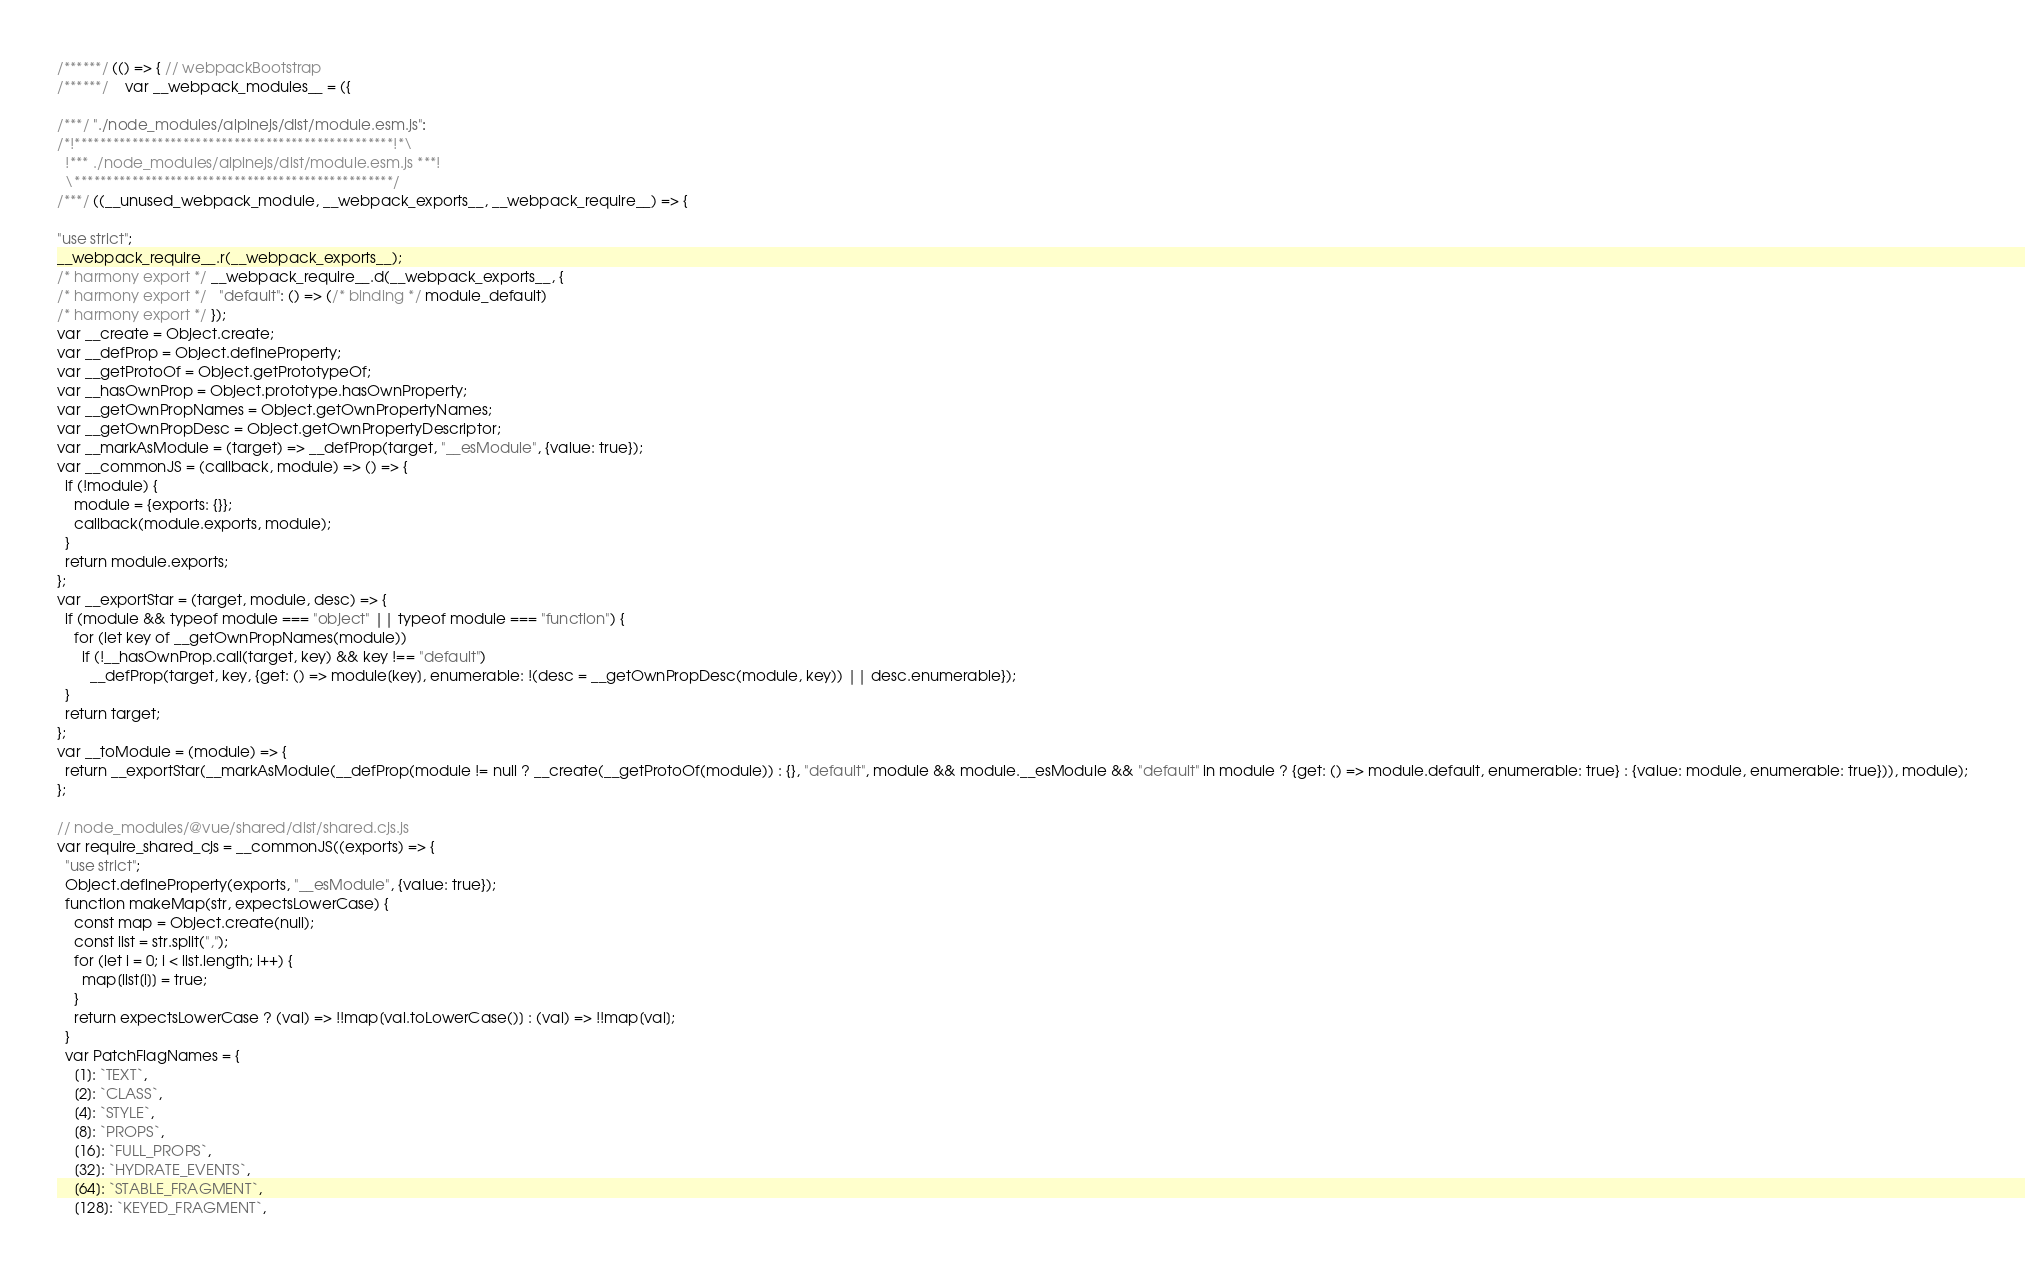Convert code to text. <code><loc_0><loc_0><loc_500><loc_500><_JavaScript_>/******/ (() => { // webpackBootstrap
/******/ 	var __webpack_modules__ = ({

/***/ "./node_modules/alpinejs/dist/module.esm.js":
/*!**************************************************!*\
  !*** ./node_modules/alpinejs/dist/module.esm.js ***!
  \**************************************************/
/***/ ((__unused_webpack_module, __webpack_exports__, __webpack_require__) => {

"use strict";
__webpack_require__.r(__webpack_exports__);
/* harmony export */ __webpack_require__.d(__webpack_exports__, {
/* harmony export */   "default": () => (/* binding */ module_default)
/* harmony export */ });
var __create = Object.create;
var __defProp = Object.defineProperty;
var __getProtoOf = Object.getPrototypeOf;
var __hasOwnProp = Object.prototype.hasOwnProperty;
var __getOwnPropNames = Object.getOwnPropertyNames;
var __getOwnPropDesc = Object.getOwnPropertyDescriptor;
var __markAsModule = (target) => __defProp(target, "__esModule", {value: true});
var __commonJS = (callback, module) => () => {
  if (!module) {
    module = {exports: {}};
    callback(module.exports, module);
  }
  return module.exports;
};
var __exportStar = (target, module, desc) => {
  if (module && typeof module === "object" || typeof module === "function") {
    for (let key of __getOwnPropNames(module))
      if (!__hasOwnProp.call(target, key) && key !== "default")
        __defProp(target, key, {get: () => module[key], enumerable: !(desc = __getOwnPropDesc(module, key)) || desc.enumerable});
  }
  return target;
};
var __toModule = (module) => {
  return __exportStar(__markAsModule(__defProp(module != null ? __create(__getProtoOf(module)) : {}, "default", module && module.__esModule && "default" in module ? {get: () => module.default, enumerable: true} : {value: module, enumerable: true})), module);
};

// node_modules/@vue/shared/dist/shared.cjs.js
var require_shared_cjs = __commonJS((exports) => {
  "use strict";
  Object.defineProperty(exports, "__esModule", {value: true});
  function makeMap(str, expectsLowerCase) {
    const map = Object.create(null);
    const list = str.split(",");
    for (let i = 0; i < list.length; i++) {
      map[list[i]] = true;
    }
    return expectsLowerCase ? (val) => !!map[val.toLowerCase()] : (val) => !!map[val];
  }
  var PatchFlagNames = {
    [1]: `TEXT`,
    [2]: `CLASS`,
    [4]: `STYLE`,
    [8]: `PROPS`,
    [16]: `FULL_PROPS`,
    [32]: `HYDRATE_EVENTS`,
    [64]: `STABLE_FRAGMENT`,
    [128]: `KEYED_FRAGMENT`,</code> 